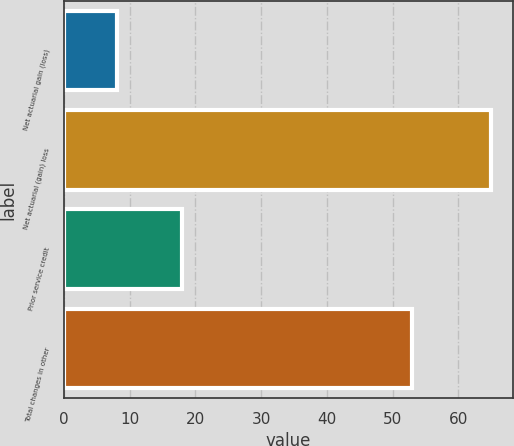Convert chart. <chart><loc_0><loc_0><loc_500><loc_500><bar_chart><fcel>Net actuarial gain (loss)<fcel>Net actuarial (gain) loss<fcel>Prior service credit<fcel>Total changes in other<nl><fcel>8<fcel>65<fcel>18<fcel>53<nl></chart> 